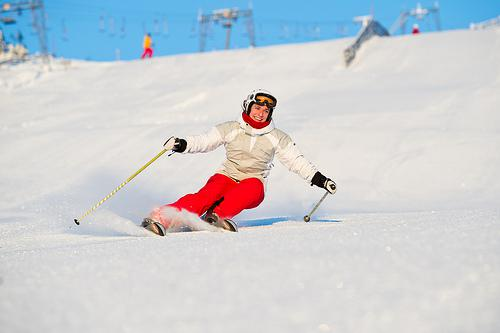Question: who is skiing?
Choices:
A. A child.
B. A woman.
C. A man.
D. The coach.
Answer with the letter. Answer: B Question: why is she leaning over?
Choices:
A. She is falling.
B. Slowing down.
C. For the cameras.
D. To turn.
Answer with the letter. Answer: D Question: what is she holding?
Choices:
A. Bottled water.
B. Cell phone.
C. Camera.
D. Ski poles.
Answer with the letter. Answer: D Question: when was the photo taken?
Choices:
A. During winter.
B. Late morning.
C. During the day.
D. After brunch.
Answer with the letter. Answer: C Question: what is the woman doing?
Choices:
A. Snowboarding.
B. Riding ski lift.
C. Competing.
D. Skiing.
Answer with the letter. Answer: D Question: where is she skiing?
Choices:
A. In the mountains.
B. At a ski resort.
C. On a ski hill.
D. In the water.
Answer with the letter. Answer: C 